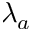<formula> <loc_0><loc_0><loc_500><loc_500>\lambda _ { a }</formula> 